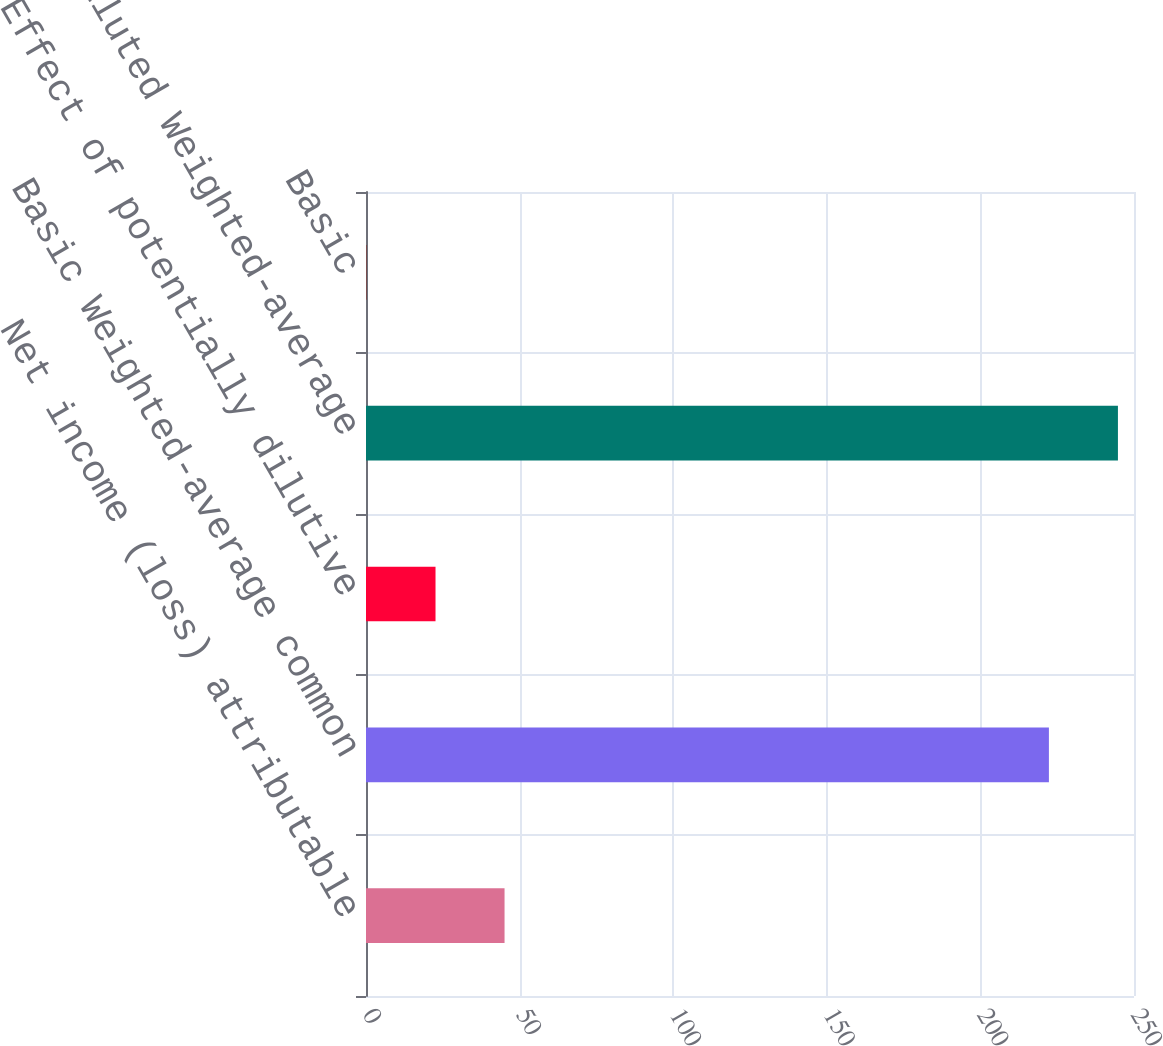Convert chart to OTSL. <chart><loc_0><loc_0><loc_500><loc_500><bar_chart><fcel>Net income (loss) attributable<fcel>Basic Weighted-average common<fcel>Effect of potentially dilutive<fcel>Diluted Weighted-average<fcel>Basic<nl><fcel>45.1<fcel>222.3<fcel>22.63<fcel>244.77<fcel>0.16<nl></chart> 